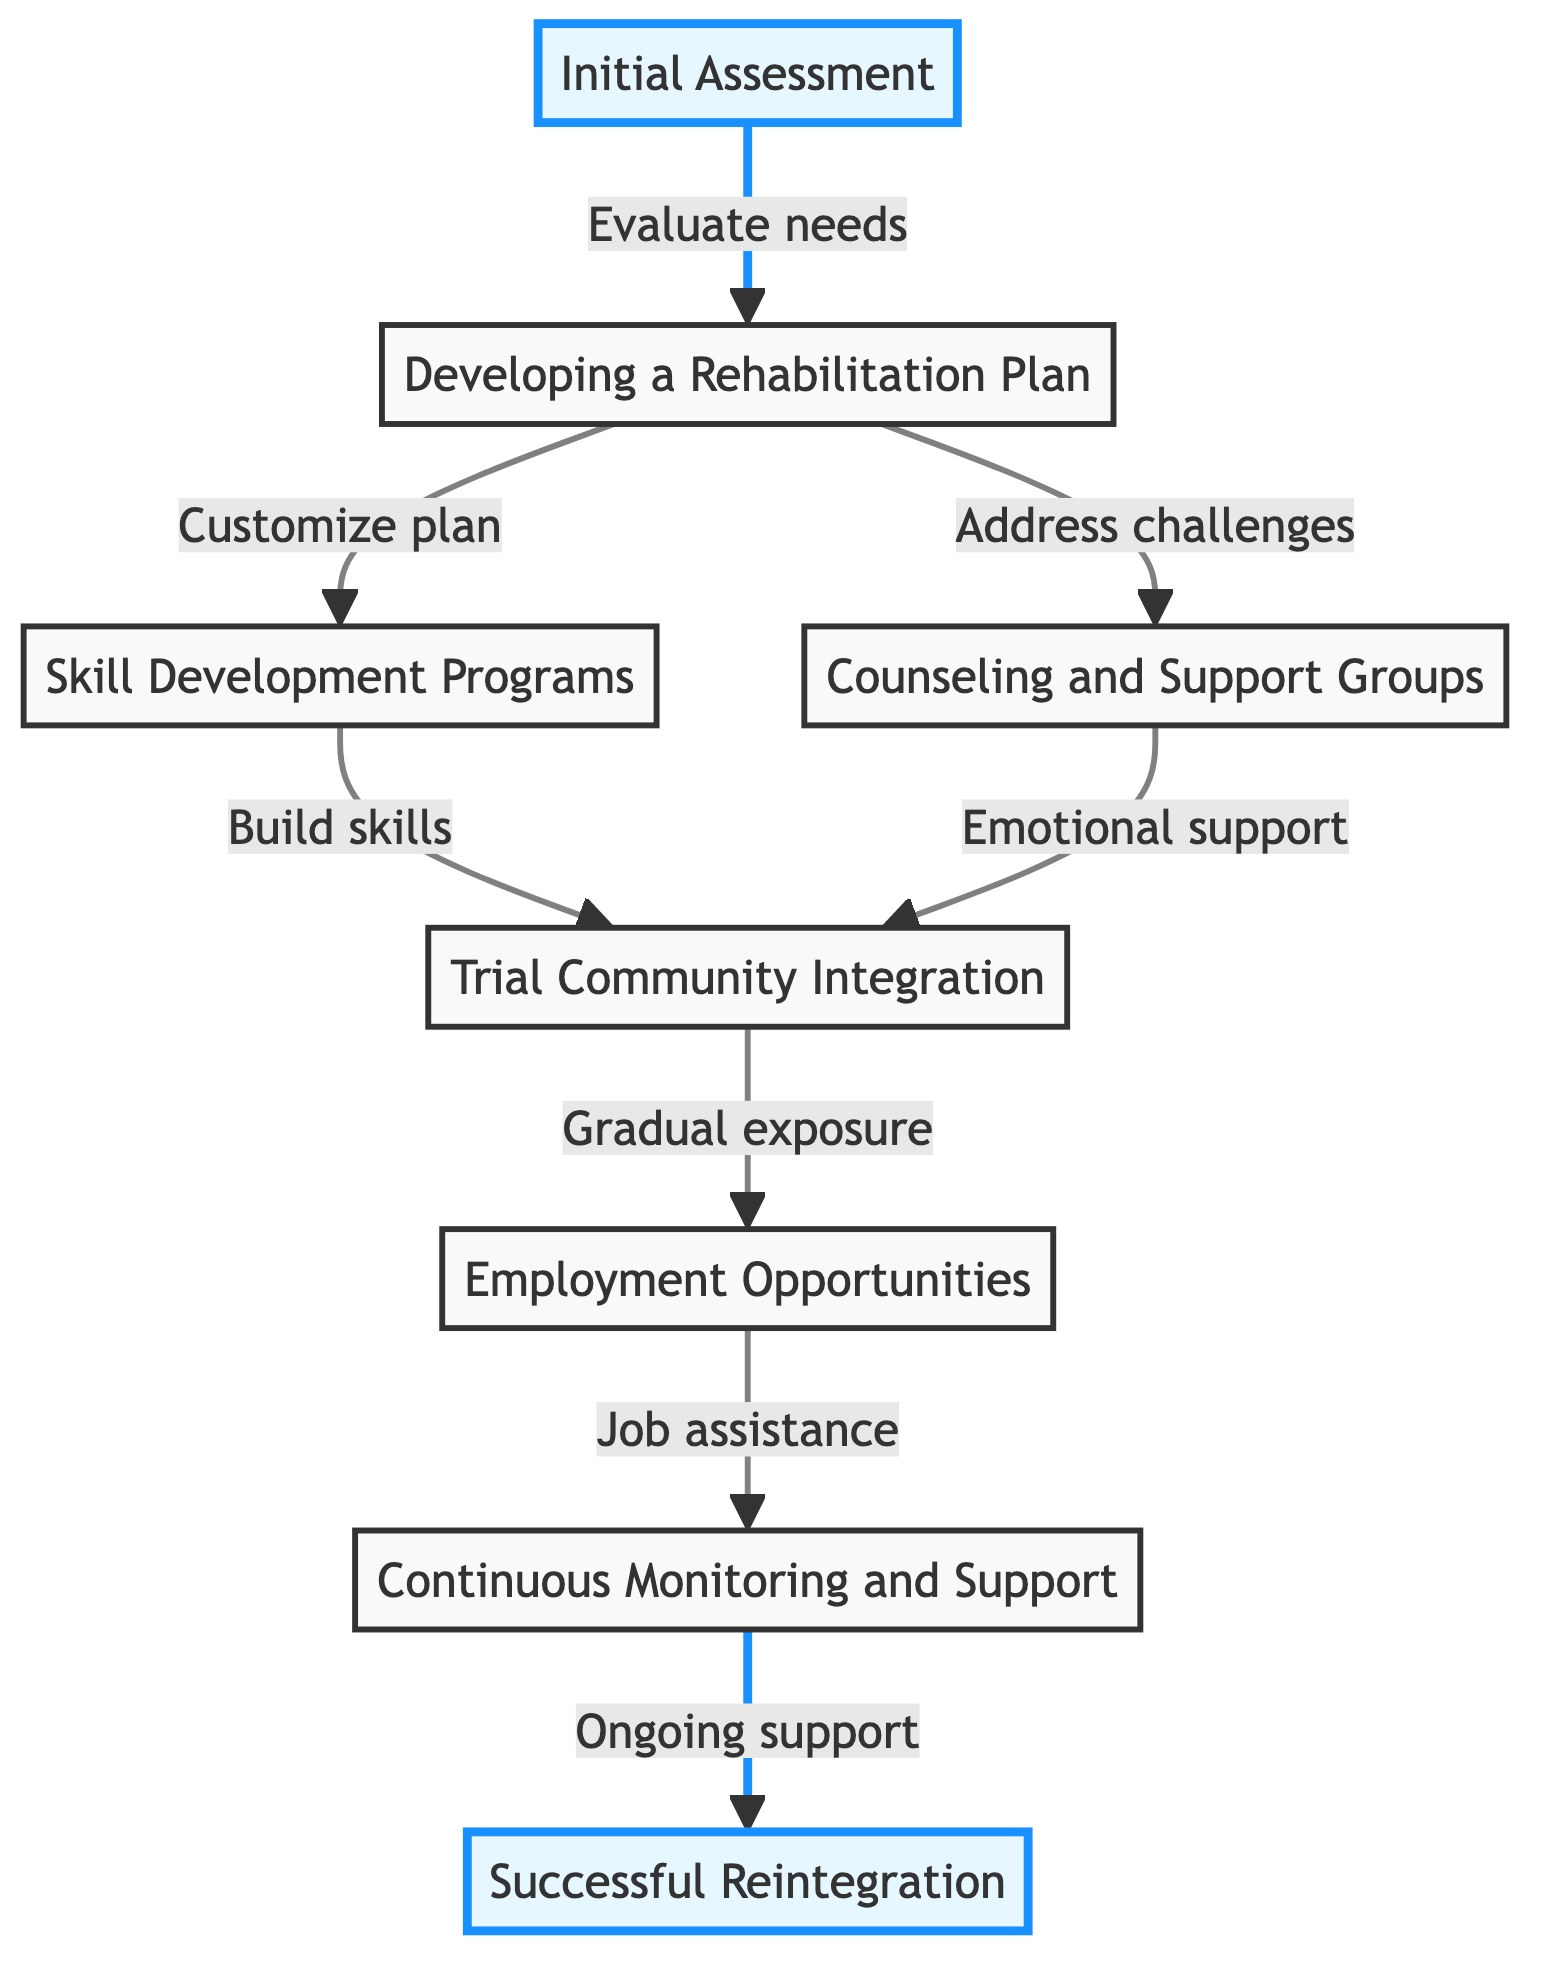What is the first stage in the rehabilitation journey? The first stage in the rehabilitation journey is indicated as "Initial Assessment", which is shown as the starting point in the flow chart.
Answer: Initial Assessment How many stages are there in total within the journey of rehabilitation? By counting all the individual stages represented in the flow chart, there are eight distinct stages from the initial assessment to successful reintegration.
Answer: 8 What does "Initial Assessment" lead to in the flowchart? "Initial Assessment" leads to two subsequent stages, namely "Developing a Rehabilitation Plan" and "Counseling and Support Groups", as shown by the arrows diverging from the first stage.
Answer: Developing a Rehabilitation Plan, Counseling and Support Groups Which stage focuses on emotional and psychological challenges? The stage that focuses on emotional and psychological challenges is "Counseling and Support Groups", where individuals engage in therapy and peer support.
Answer: Counseling and Support Groups How does "Skill Development Programs" connect to "Trial Community Integration"? "Skill Development Programs" connects to "Trial Community Integration" by indicating that skill development leads to gradual exposure to community environments through supervised activities, as represented by the directed arrow from one to the other.
Answer: Gradual exposure Which stages are highlighted in the flowchart? The highlighted stages are "Initial Assessment" and "Successful Reintegration", which are visually distinguished from the others by the use of highlighting styles.
Answer: Initial Assessment, Successful Reintegration What support is provided in the stage of "Continuous Monitoring and Support"? In the "Continuous Monitoring and Support" stage, ongoing evaluation and encouragement come from mentors and community programs, as specified in the description of that stage.
Answer: Ongoing evaluation and encouragement What is the outcome of "Successful Reintegration"? The outcome of "Successful Reintegration" is achieving a stable lifestyle, maintaining employment, and rebuilding social connections, which are summarized in the final stage of the flowchart.
Answer: Achieving a stable lifestyle, maintaining employment, rebuilding social connections 